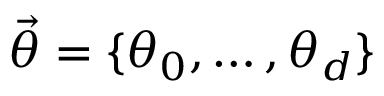<formula> <loc_0><loc_0><loc_500><loc_500>\vec { \theta } = \{ \theta _ { 0 } , \dots , \theta _ { d } \}</formula> 